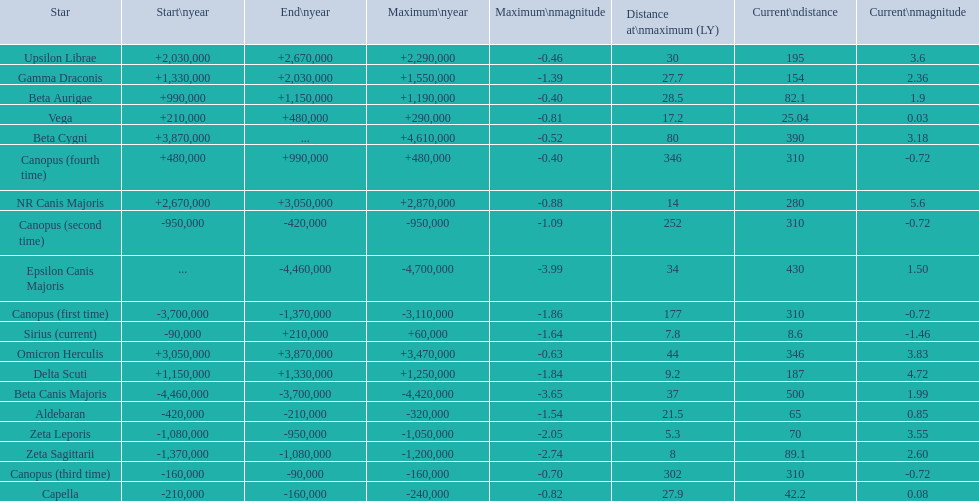Is capella's current magnitude more than vega's current magnitude? Yes. 